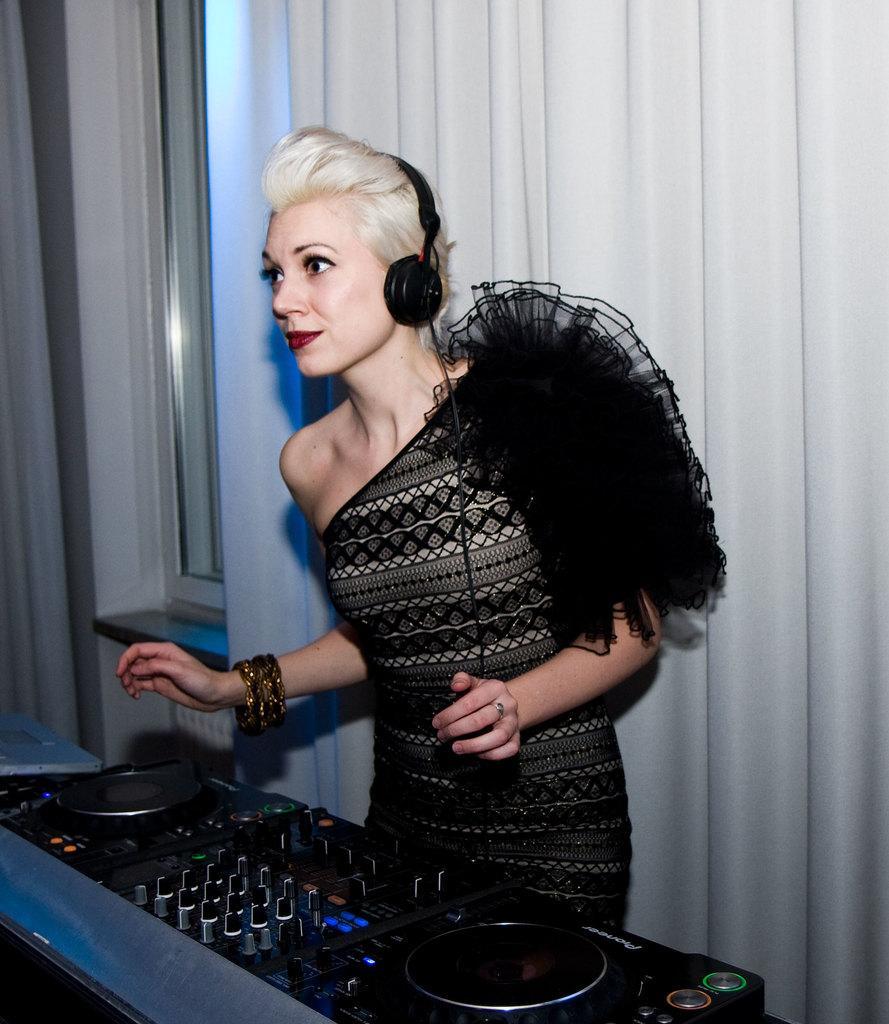Describe this image in one or two sentences. In the background we can see curtains, window. In this picture we can see a woman wearing a headset and she is standing. At the bottom portion of the picture we can see a disc jockey device. 